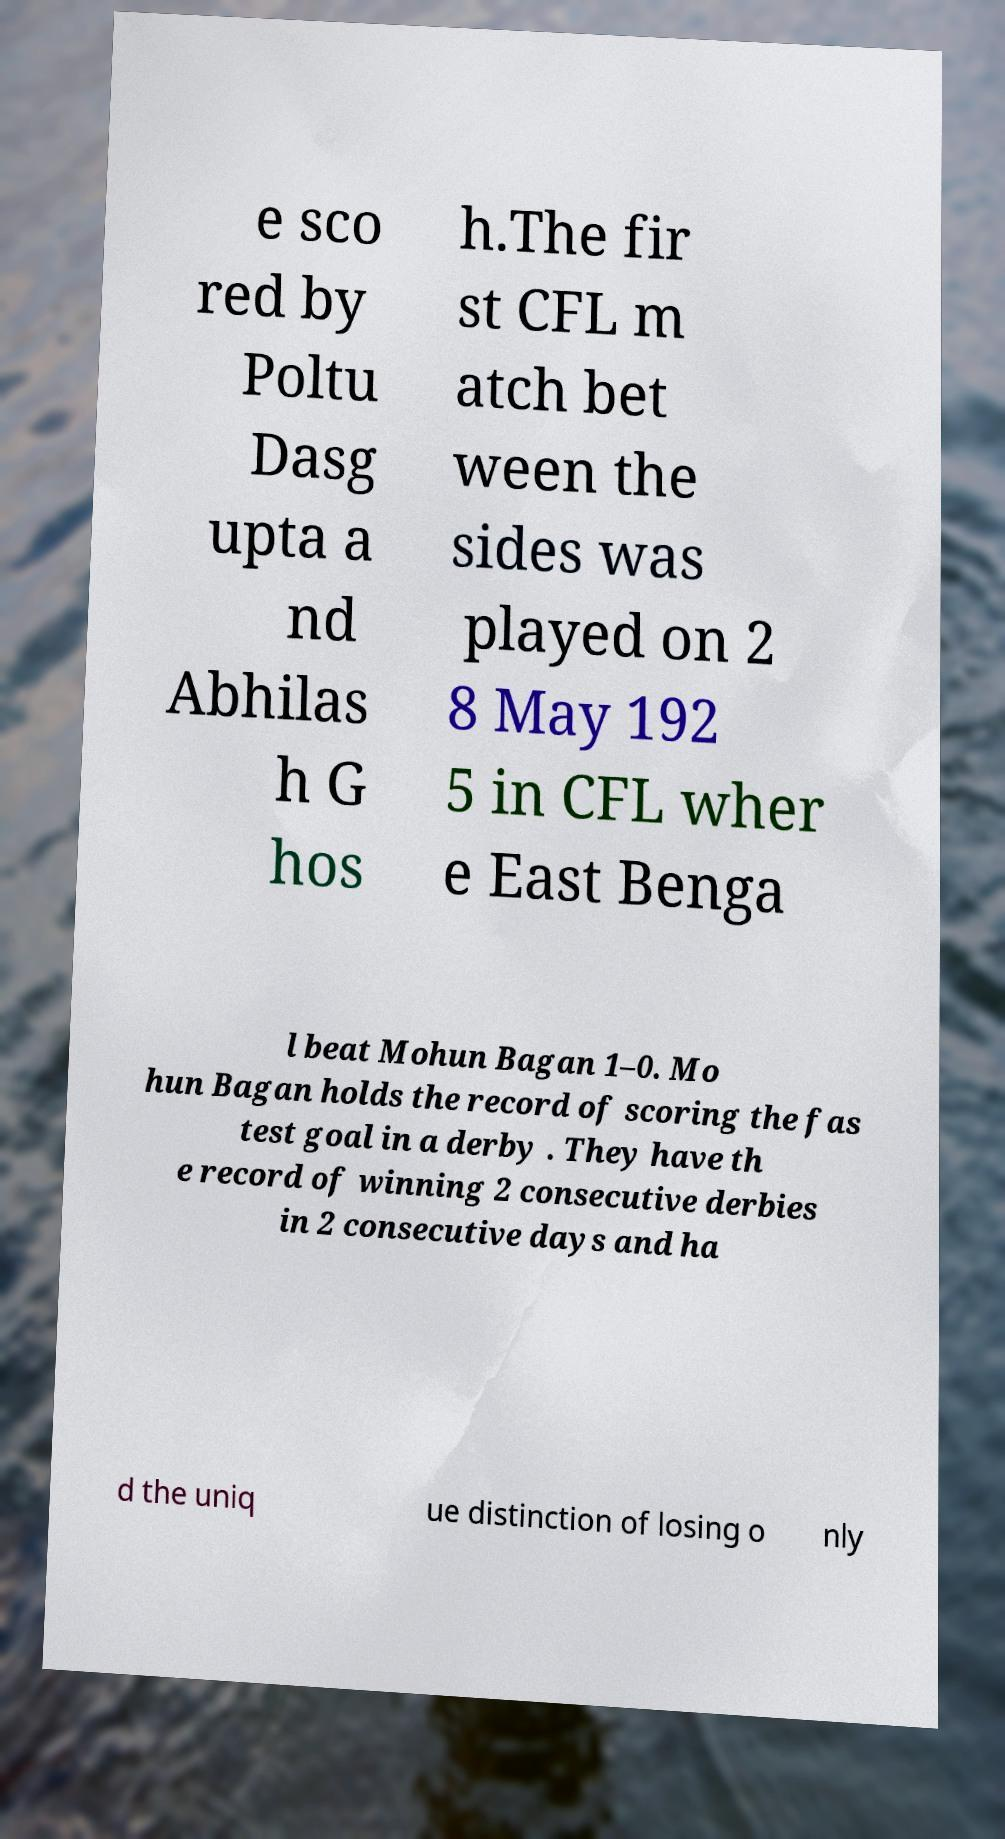Can you read and provide the text displayed in the image?This photo seems to have some interesting text. Can you extract and type it out for me? e sco red by Poltu Dasg upta a nd Abhilas h G hos h.The fir st CFL m atch bet ween the sides was played on 2 8 May 192 5 in CFL wher e East Benga l beat Mohun Bagan 1–0. Mo hun Bagan holds the record of scoring the fas test goal in a derby . They have th e record of winning 2 consecutive derbies in 2 consecutive days and ha d the uniq ue distinction of losing o nly 